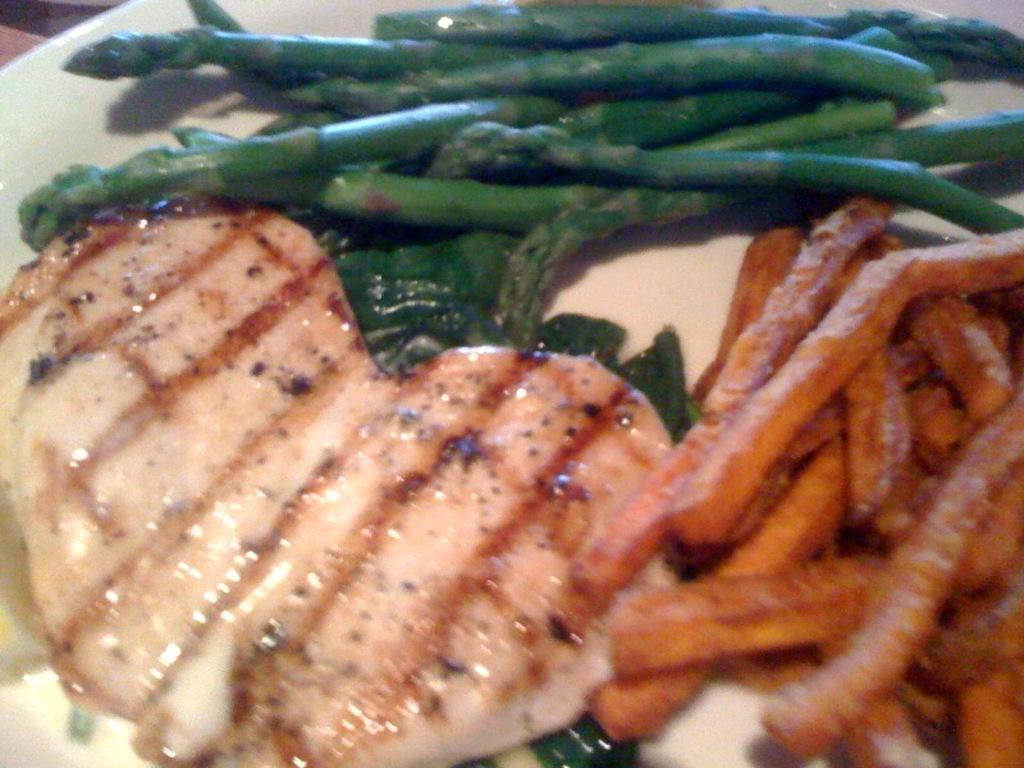Could you give a brief overview of what you see in this image? In this image there is one plate, in that place there are some food items and french fries. 